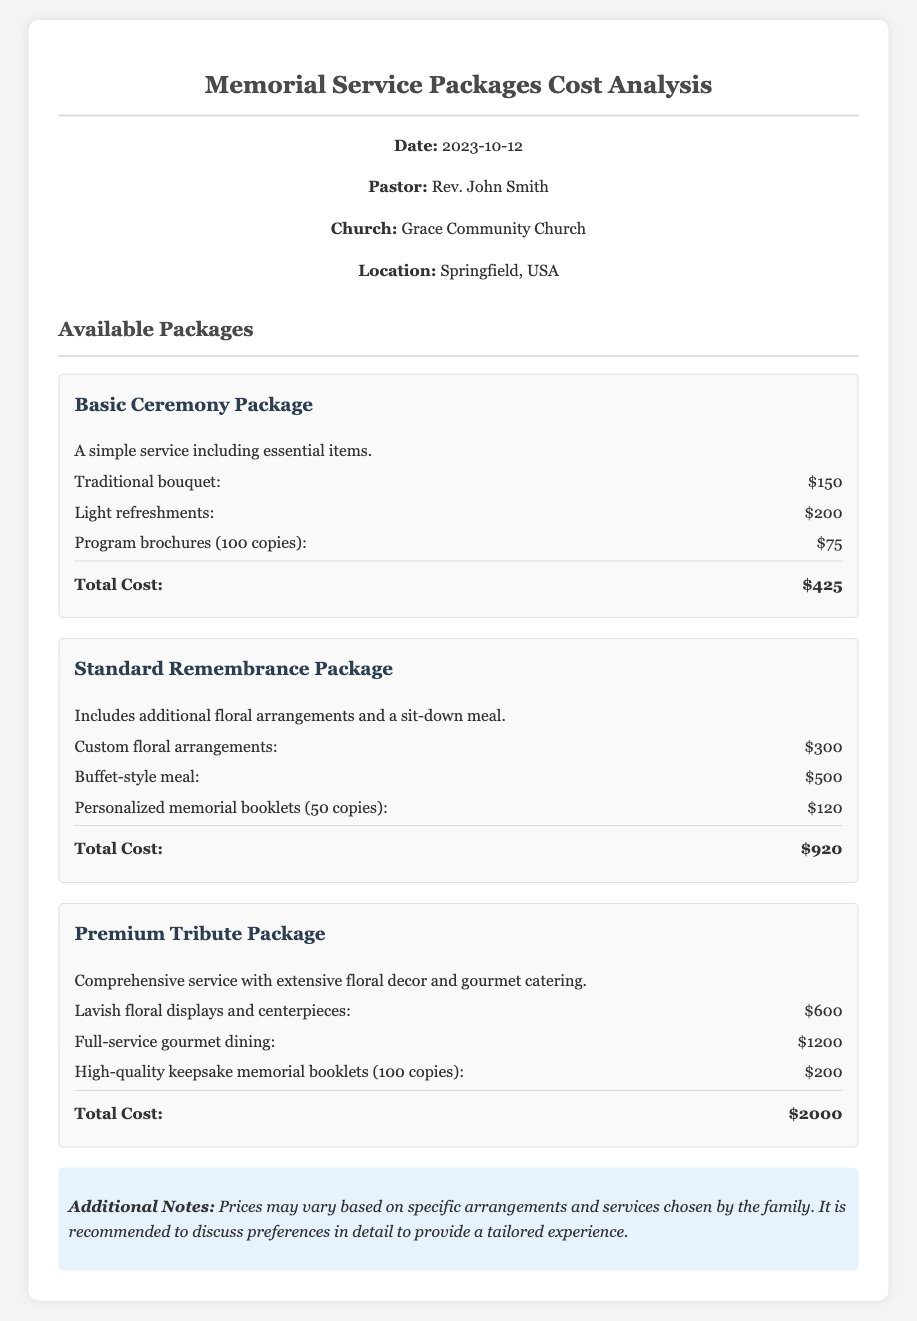What is the date of the report? The date of the report is clearly stated in the header section of the document.
Answer: 2023-10-12 Who is the pastor mentioned in the report? The name of the pastor is provided in the header information section.
Answer: Rev. John Smith How much does the Basic Ceremony Package cost? The total cost for the Basic Ceremony Package is listed in the itemized financial overview of the packages.
Answer: $425 What item is included in the Standard Remembrance Package related to meals? The document specifies a meal included in the Standard Remembrance Package section.
Answer: Buffet-style meal Which package has the highest total cost? The document includes several packages with their respective total costs, allowing a comparison to determine which one is highest.
Answer: Premium Tribute Package What is the total cost of the Premium Tribute Package? The total cost for the Premium Tribute Package is provided at the end of that package description.
Answer: $2000 What type of refreshments are offered in the Basic Ceremony Package? The type of refreshments is specified in the itemized list for the Basic Ceremony Package.
Answer: Light refreshments What additional item is included in the Premium Tribute Package compared to the Standard Remembrance Package? The document details the inclusions in both packages, allowing a comparison of additional features.
Answer: Lavish floral displays and centerpieces What note is provided regarding pricing variability? The notes section of the document includes information about the variability of prices, which is important for understanding costs.
Answer: Prices may vary based on specific arrangements and services chosen by the family 